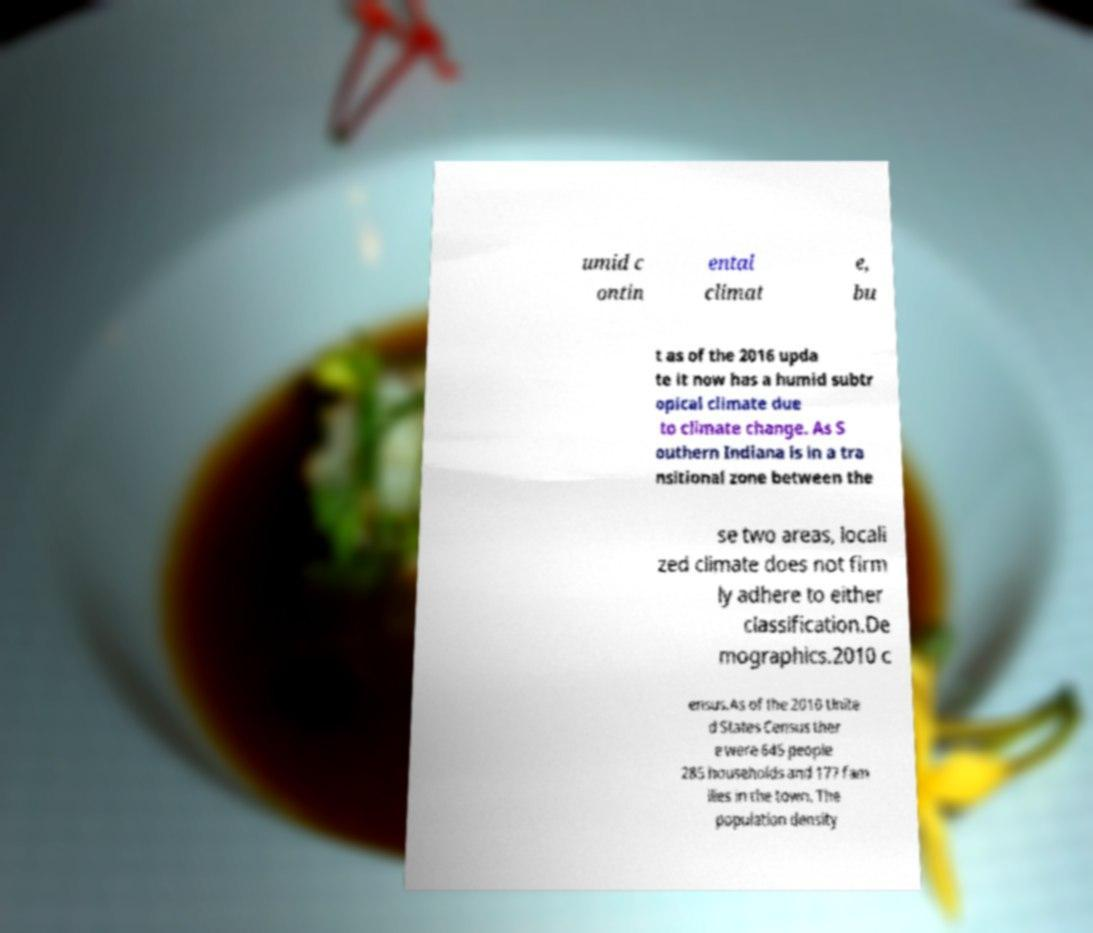Can you accurately transcribe the text from the provided image for me? umid c ontin ental climat e, bu t as of the 2016 upda te it now has a humid subtr opical climate due to climate change. As S outhern Indiana is in a tra nsitional zone between the se two areas, locali zed climate does not firm ly adhere to either classification.De mographics.2010 c ensus.As of the 2010 Unite d States Census ther e were 645 people 285 households and 177 fam ilies in the town. The population density 